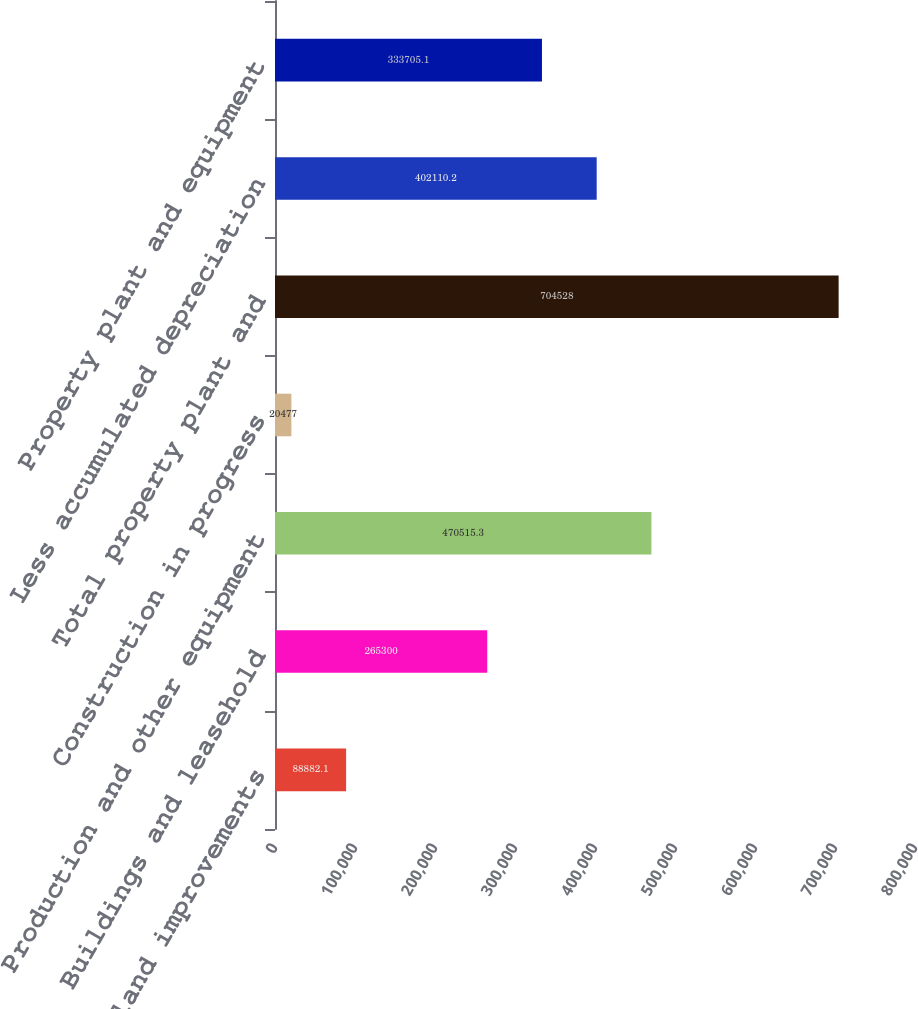Convert chart to OTSL. <chart><loc_0><loc_0><loc_500><loc_500><bar_chart><fcel>Land and land improvements<fcel>Buildings and leasehold<fcel>Production and other equipment<fcel>Construction in progress<fcel>Total property plant and<fcel>Less accumulated depreciation<fcel>Property plant and equipment<nl><fcel>88882.1<fcel>265300<fcel>470515<fcel>20477<fcel>704528<fcel>402110<fcel>333705<nl></chart> 